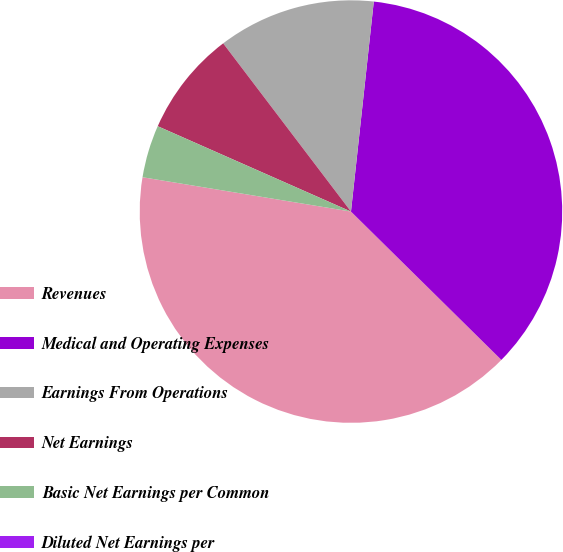Convert chart. <chart><loc_0><loc_0><loc_500><loc_500><pie_chart><fcel>Revenues<fcel>Medical and Operating Expenses<fcel>Earnings From Operations<fcel>Net Earnings<fcel>Basic Net Earnings per Common<fcel>Diluted Net Earnings per<nl><fcel>40.2%<fcel>35.66%<fcel>12.06%<fcel>8.04%<fcel>4.02%<fcel>0.0%<nl></chart> 